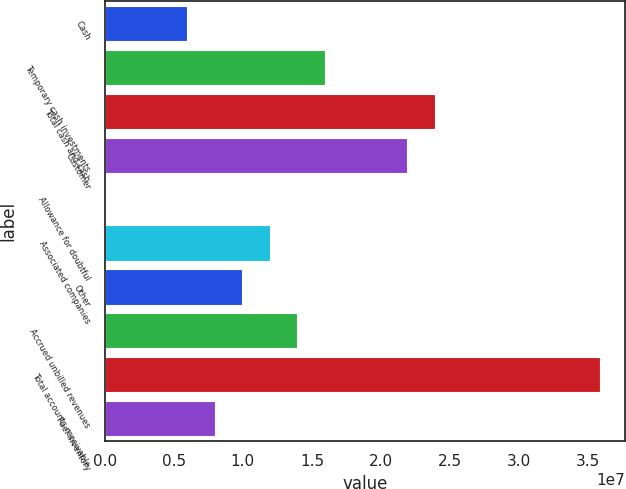Convert chart. <chart><loc_0><loc_0><loc_500><loc_500><bar_chart><fcel>Cash<fcel>Temporary cash investments<fcel>Total cash and cash<fcel>Customer<fcel>Allowance for doubtful<fcel>Associated companies<fcel>Other<fcel>Accrued unbilled revenues<fcel>Total accounts receivable<fcel>Fuel inventory<nl><fcel>5.9805e+06<fcel>1.59375e+07<fcel>2.39032e+07<fcel>2.19118e+07<fcel>6277<fcel>1.19547e+07<fcel>9.96332e+06<fcel>1.39461e+07<fcel>3.58516e+07<fcel>7.97191e+06<nl></chart> 